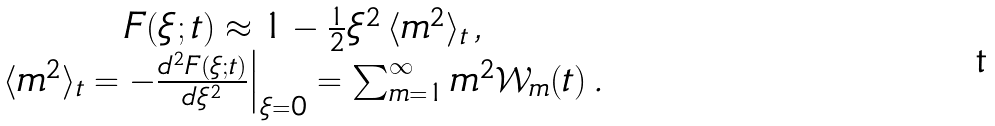Convert formula to latex. <formula><loc_0><loc_0><loc_500><loc_500>\begin{array} { c } F ( \xi ; t ) \approx 1 - \frac { 1 } { 2 } \xi ^ { 2 } \, \langle m ^ { 2 } \rangle _ { t } \, , \\ \langle m ^ { 2 } \rangle _ { t } = - \frac { d ^ { 2 } F ( \xi ; t ) } { d \xi ^ { 2 } } \Big | _ { \xi = 0 } = \sum _ { m = 1 } ^ { \infty } m ^ { 2 } \mathcal { W } _ { m } ( t ) \, . \end{array}</formula> 